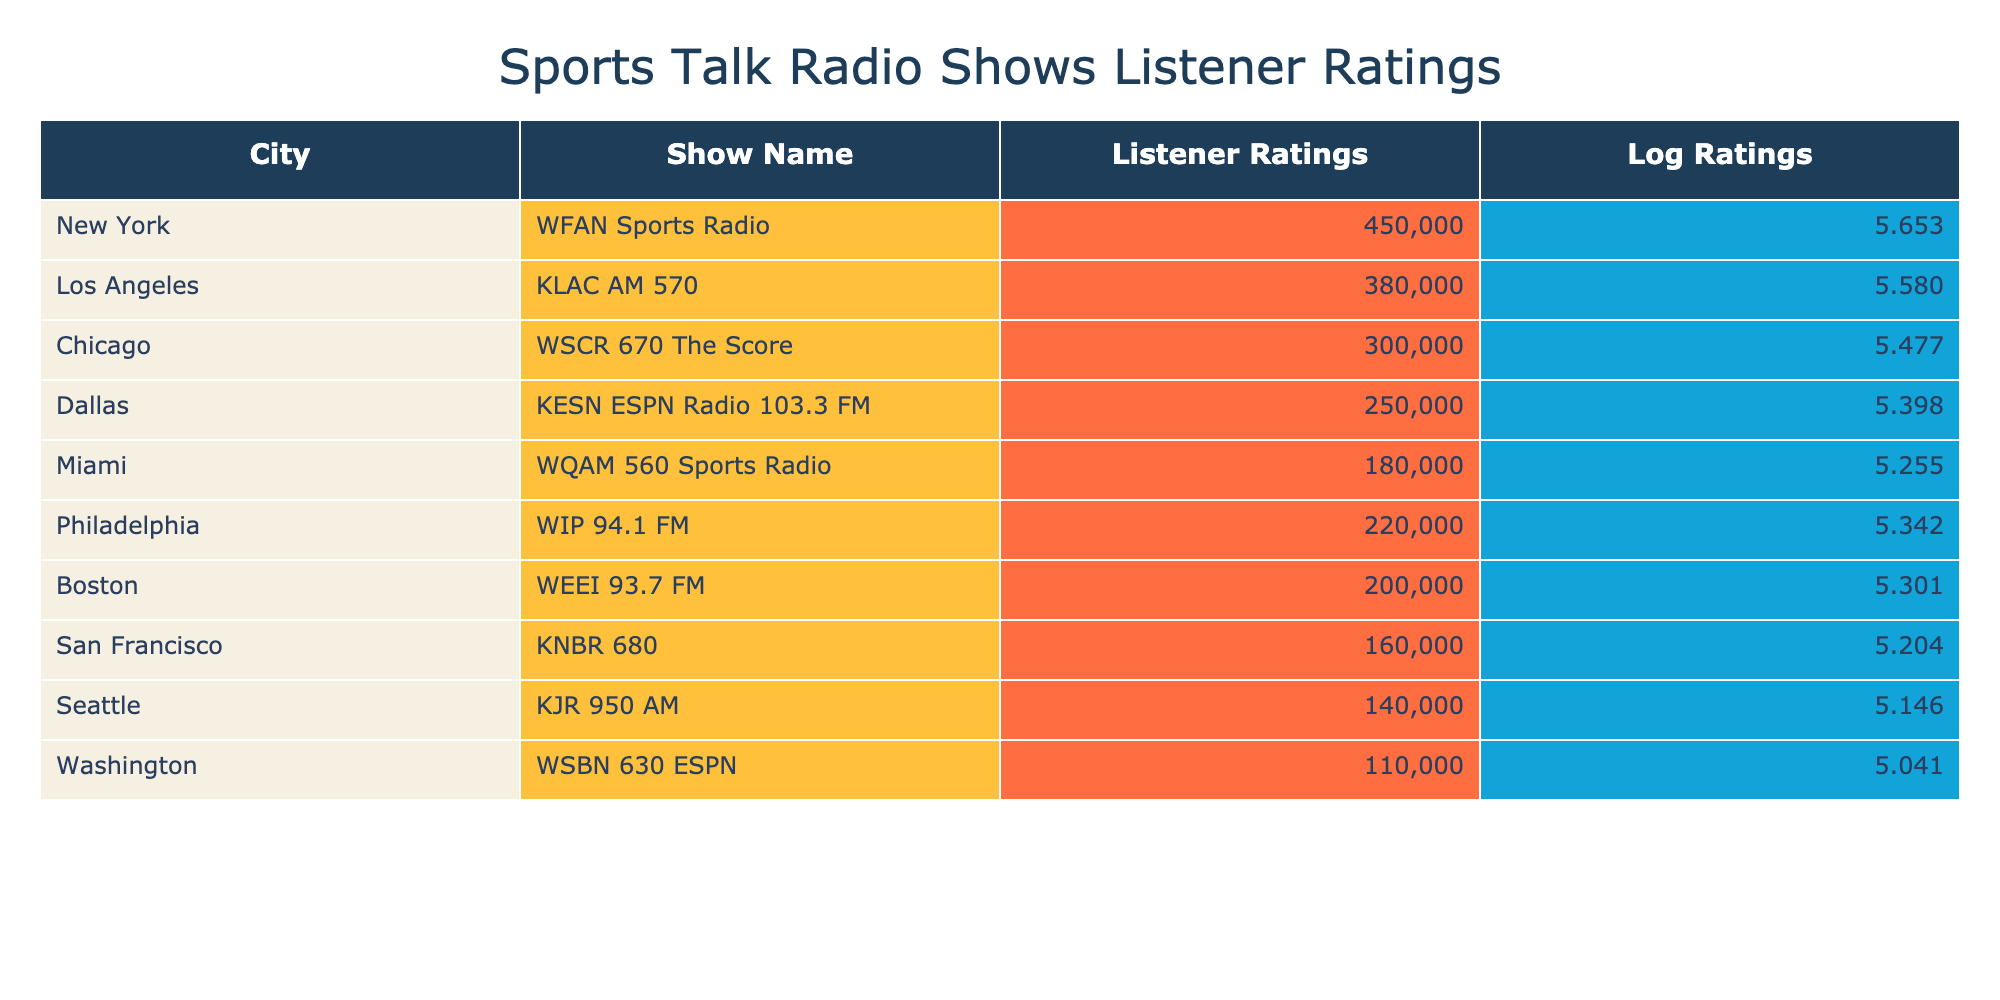What city has the highest listener ratings? By looking at the “Listener Ratings” column, we can see that New York shows the highest number, which is 450000.
Answer: New York What is the listener rating for Philadelphia's sports radio show? The table lists Philadelphia’s show, WIP 94.1 FM, with a listener rating of 220000.
Answer: 220000 How many more listener ratings does WFAN Sports Radio have than KESN ESPN Radio 103.3 FM? To find the difference, we subtract KESN's rating (250000) from WFAN's rating (450000), giving us 450000 - 250000 = 200000.
Answer: 200000 What is the average listener rating of the radio shows listed? To calculate the average, we first sum all the listener ratings: 450000 + 380000 + 300000 + 250000 + 180000 + 220000 + 200000 + 160000 + 140000 + 110000 = 1990000. Then, divide by 10 (the number of shows), yielding an average of 1990000 / 10 = 199000.
Answer: 199000 Does Seattle's KJR 950 AM have a higher listener rating than Boston's WEEI 93.7 FM? From the listener ratings, KJR has 140000 while WEEI has 200000. Since 140000 is less than 200000, the answer is no.
Answer: No Which city has the lowest listener ratings? By examining the ratings, we find that Washington has the lowest rating at 110000.
Answer: Washington What are the logarithmic values for the listener ratings of KLAC AM 570? The listener rating for KLAC AM 570 is 380000. When we take the logarithm base 10 of 380000, we get approximately 5.579.
Answer: Approximately 5.579 Which radio show's ratings are closest to 200000? Checking the ratings, we see that WIP 94.1 FM has a rating of 220000, which is the closest value above 200000, while WEEI 93.7 FM is exactly 200000. Hence, WEEI is the answer.
Answer: WEEI 93.7 FM How does the listener rating of KNBR 680 compare to WQAM 560 Sports Radio? KNBR has a rating of 160000 and WQAM has 180000. 160000 is less than 180000, showing that KNBR has lower ratings than WQAM.
Answer: Lower 